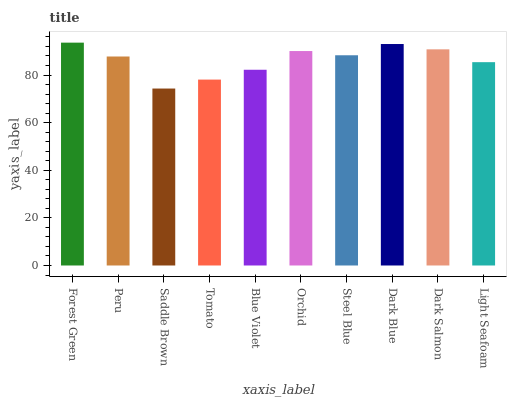Is Saddle Brown the minimum?
Answer yes or no. Yes. Is Forest Green the maximum?
Answer yes or no. Yes. Is Peru the minimum?
Answer yes or no. No. Is Peru the maximum?
Answer yes or no. No. Is Forest Green greater than Peru?
Answer yes or no. Yes. Is Peru less than Forest Green?
Answer yes or no. Yes. Is Peru greater than Forest Green?
Answer yes or no. No. Is Forest Green less than Peru?
Answer yes or no. No. Is Steel Blue the high median?
Answer yes or no. Yes. Is Peru the low median?
Answer yes or no. Yes. Is Blue Violet the high median?
Answer yes or no. No. Is Steel Blue the low median?
Answer yes or no. No. 